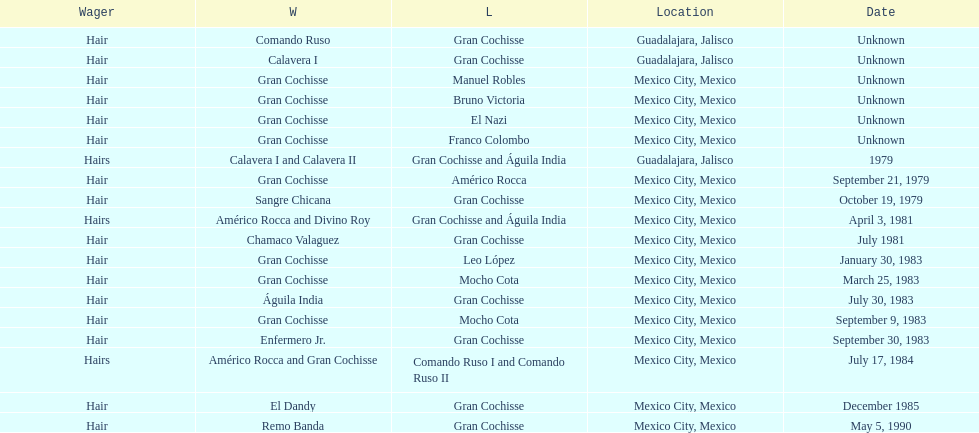When was gran chochisse first match that had a full date on record? September 21, 1979. 